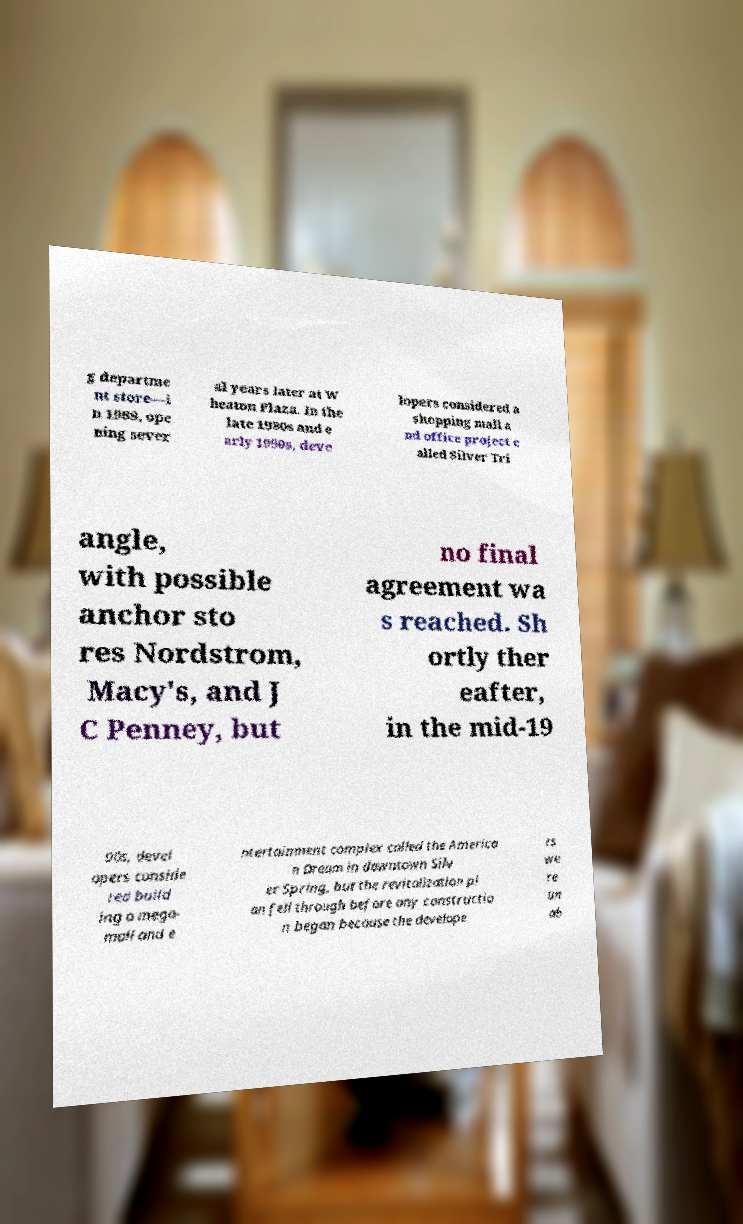Can you read and provide the text displayed in the image?This photo seems to have some interesting text. Can you extract and type it out for me? g departme nt store—i n 1989, ope ning sever al years later at W heaton Plaza. In the late 1980s and e arly 1990s, deve lopers considered a shopping mall a nd office project c alled Silver Tri angle, with possible anchor sto res Nordstrom, Macy's, and J C Penney, but no final agreement wa s reached. Sh ortly ther eafter, in the mid-19 90s, devel opers conside red build ing a mega- mall and e ntertainment complex called the America n Dream in downtown Silv er Spring, but the revitalization pl an fell through before any constructio n began because the develope rs we re un ab 